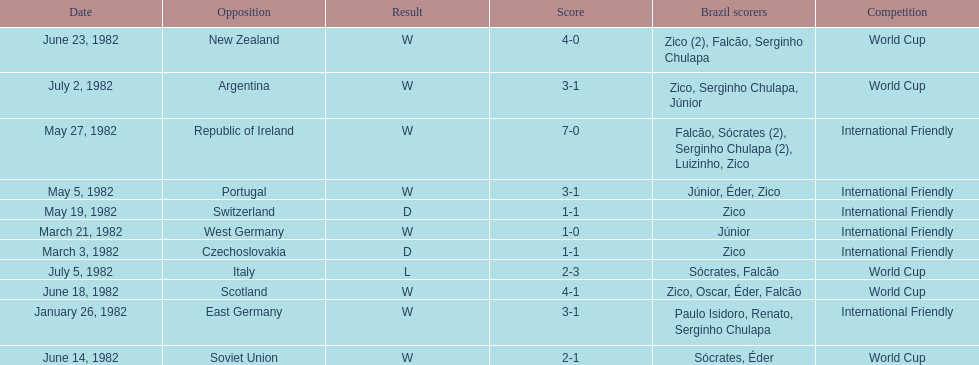Can you give me this table as a dict? {'header': ['Date', 'Opposition', 'Result', 'Score', 'Brazil scorers', 'Competition'], 'rows': [['June 23, 1982', 'New Zealand', 'W', '4-0', 'Zico (2), Falcão, Serginho Chulapa', 'World Cup'], ['July 2, 1982', 'Argentina', 'W', '3-1', 'Zico, Serginho Chulapa, Júnior', 'World Cup'], ['May 27, 1982', 'Republic of Ireland', 'W', '7-0', 'Falcão, Sócrates (2), Serginho Chulapa (2), Luizinho, Zico', 'International Friendly'], ['May 5, 1982', 'Portugal', 'W', '3-1', 'Júnior, Éder, Zico', 'International Friendly'], ['May 19, 1982', 'Switzerland', 'D', '1-1', 'Zico', 'International Friendly'], ['March 21, 1982', 'West Germany', 'W', '1-0', 'Júnior', 'International Friendly'], ['March 3, 1982', 'Czechoslovakia', 'D', '1-1', 'Zico', 'International Friendly'], ['July 5, 1982', 'Italy', 'L', '2-3', 'Sócrates, Falcão', 'World Cup'], ['June 18, 1982', 'Scotland', 'W', '4-1', 'Zico, Oscar, Éder, Falcão', 'World Cup'], ['January 26, 1982', 'East Germany', 'W', '3-1', 'Paulo Isidoro, Renato, Serginho Chulapa', 'International Friendly'], ['June 14, 1982', 'Soviet Union', 'W', '2-1', 'Sócrates, Éder', 'World Cup']]} Who won on january 26, 1982 and may 27, 1982? Brazil. 